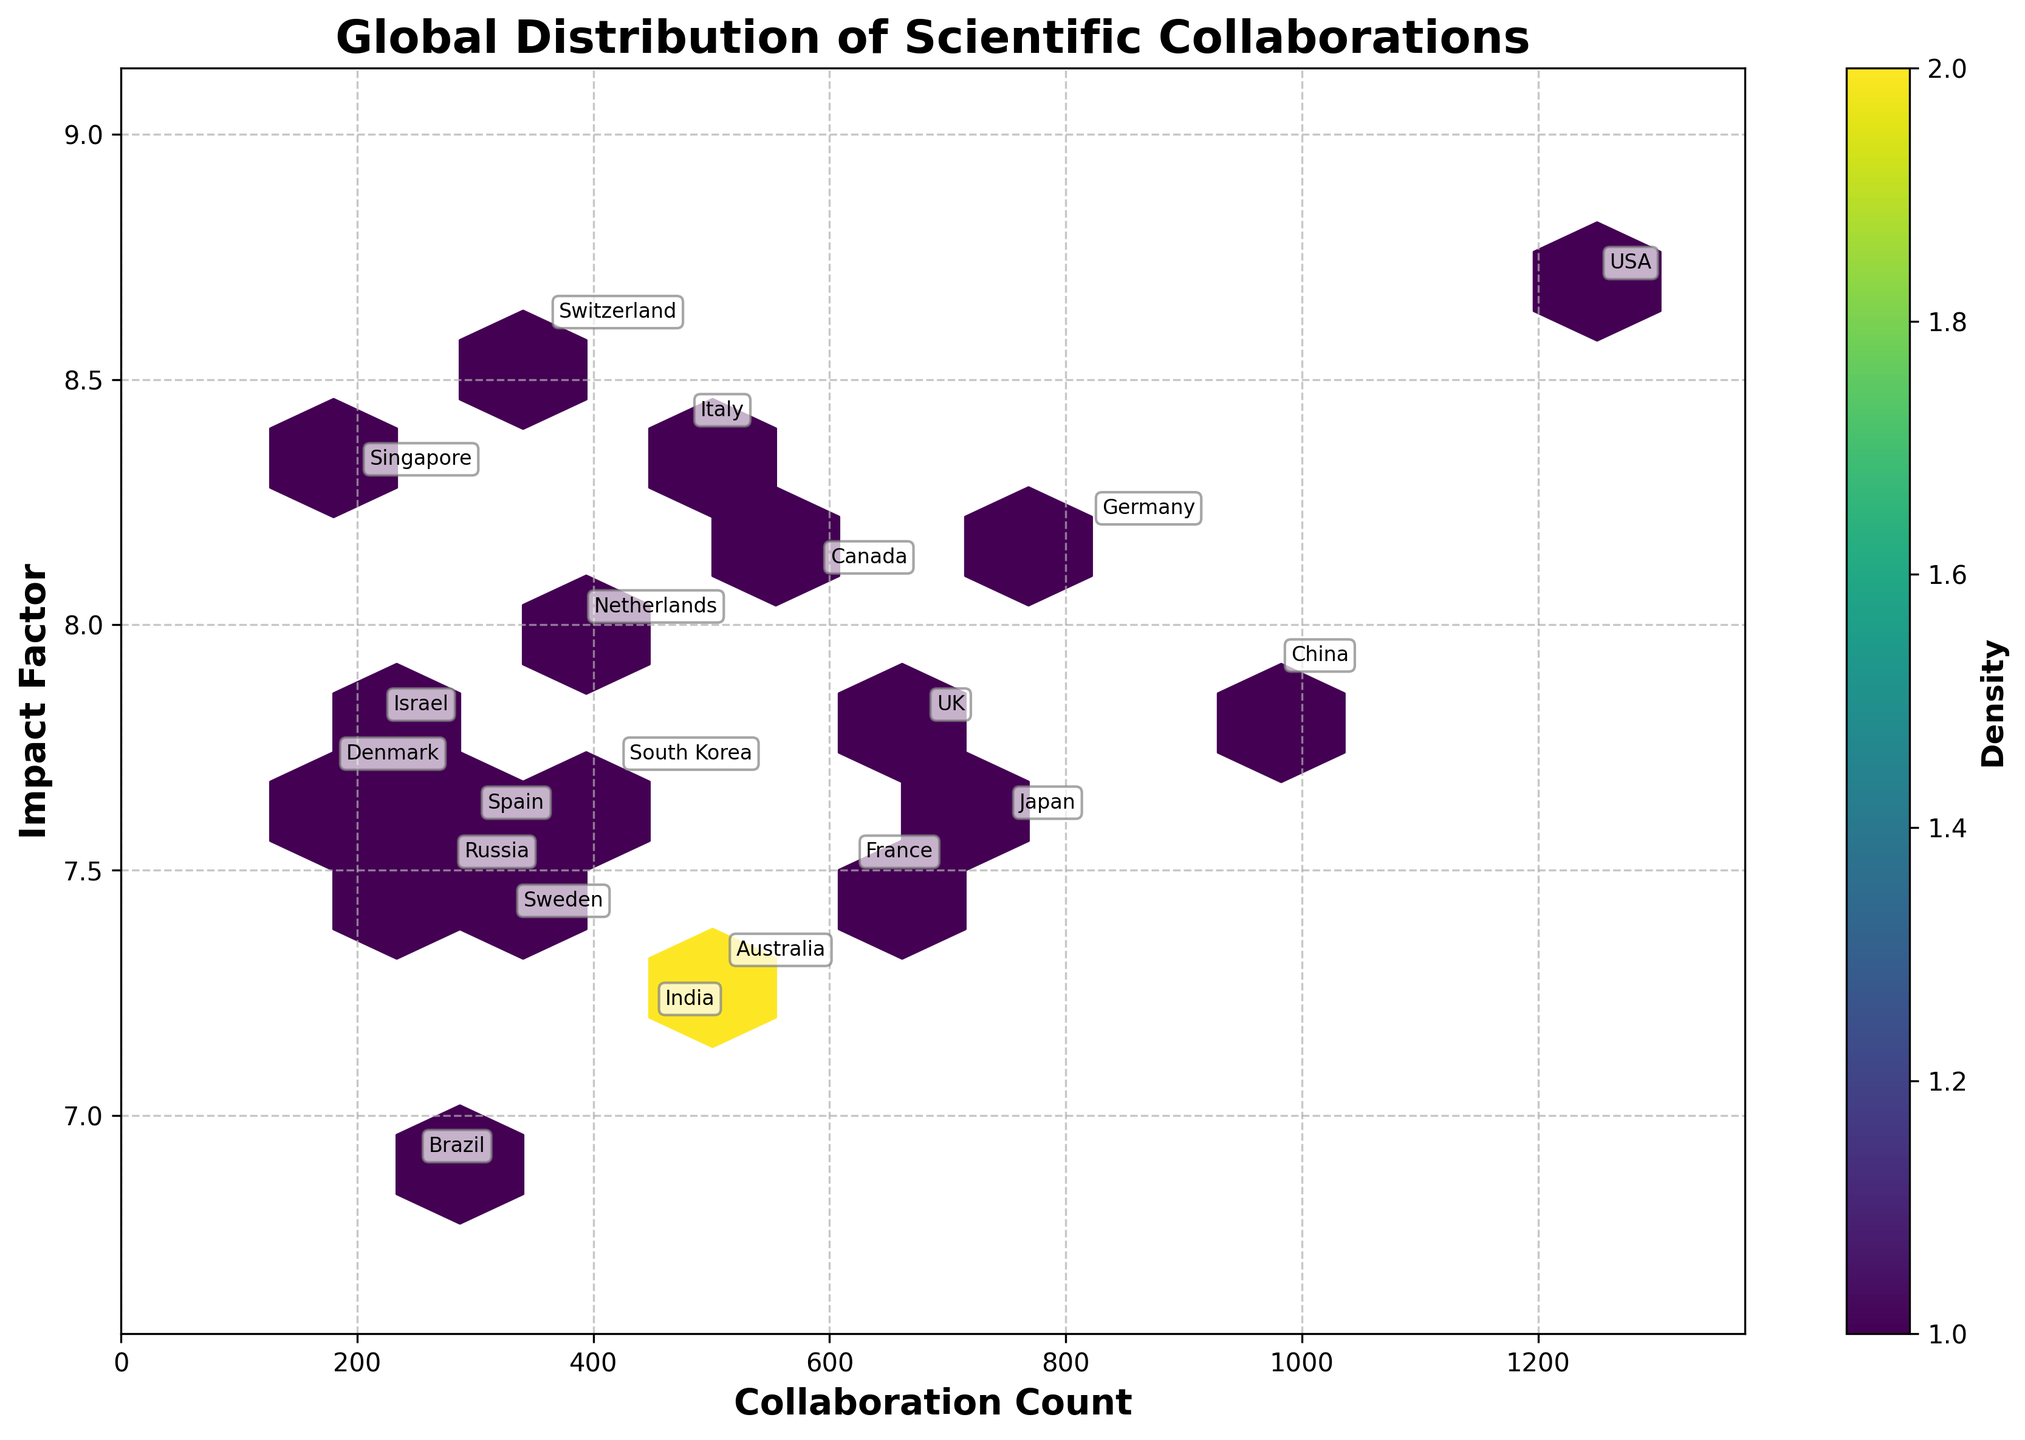What is the title of the plot? The title can be found at the top of the plot.
Answer: Global Distribution of Scientific Collaborations What does the color of the hexagons represent in the plot? The color of the hexagons represents the density of the data points within that region. Darker colors indicate higher densities.
Answer: Density Which two countries have the highest collaboration counts? The x-axis denotes the collaboration count, making it easy to identify the countries with the highest values. USA has the highest count at 1250, followed by China at 980.
Answer: USA and China What is the impact factor for Italy in Astrophysics? Using the axis labels and annotations, you can locate Italy and find its data point. Italy's impact factor is at the position annotated.
Answer: 8.4 How many countries have an impact factor higher than 8.0? The y-axis represents the impact factor. By counting the annotations above the 8.0 threshold, we can determine there are five such countries: USA, Germany, Canada, Netherlands, and Switzerland.
Answer: 5 Which country has the highest impact factor and in what research area? The y-axis represents impact factor, so we can find the highest point annotated as USA in Quantum Computing.
Answer: USA, Quantum Computing For countries with similar impact factors (around 7.8), compare their collaboration counts. Countries like the UK, Israel, China, and Denmark have impact factors around 7.8. The collaboration counts are ordered: China (980), UK (680), Israel (220), Denmark (180).
Answer: China > UK > Israel > Denmark What is the median collaboration count in the dataset? To find the median, you list all collaboration counts in ascending order and find the middle value. The ordered counts are 180, 200, 220, 250, 280, 300, 330, 360, 390, 420, 450, 480, 510, 590, 620, 680, 750, 820, 980, 1250. The middle values (10th and 11th) are 420 and 450, so the median is (420 + 450) / 2 = 435.
Answer: 435 What's the total collaboration count for countries with an impact factor above 8.0? Sum the collaboration counts for USA (1250), Germany (820), Canada (590), Netherlands (390), and Switzerland (360). Total = 1250 + 820 + 590 + 390 + 360 = 3410.
Answer: 3410 How does the density of collaborations vary with respect to collaboration count and impact factor? The density can be inferred from the color shades of the hexes; denser areas are darker. Higher densities tend to cluster around lower and mid-range collaboration counts with average impact factors.
Answer: Varies, darker for mid-range collaborations and average impact factors 